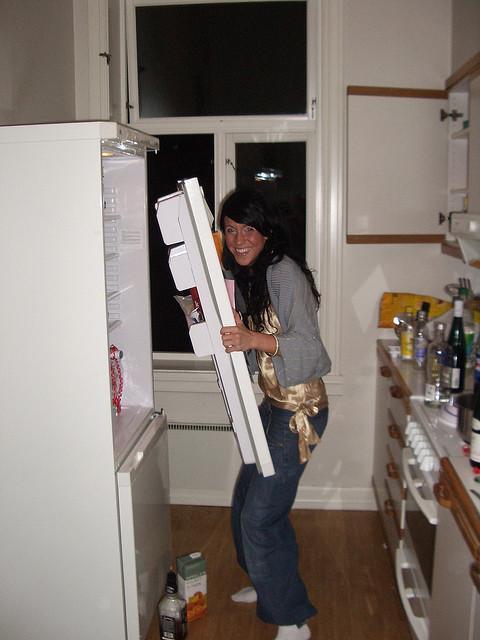What will happen to the refrigerator next?
From the following set of four choices, select the accurate answer to respond to the question.
Options: Nothing, chilling, freezing, warm up. Warm up. 